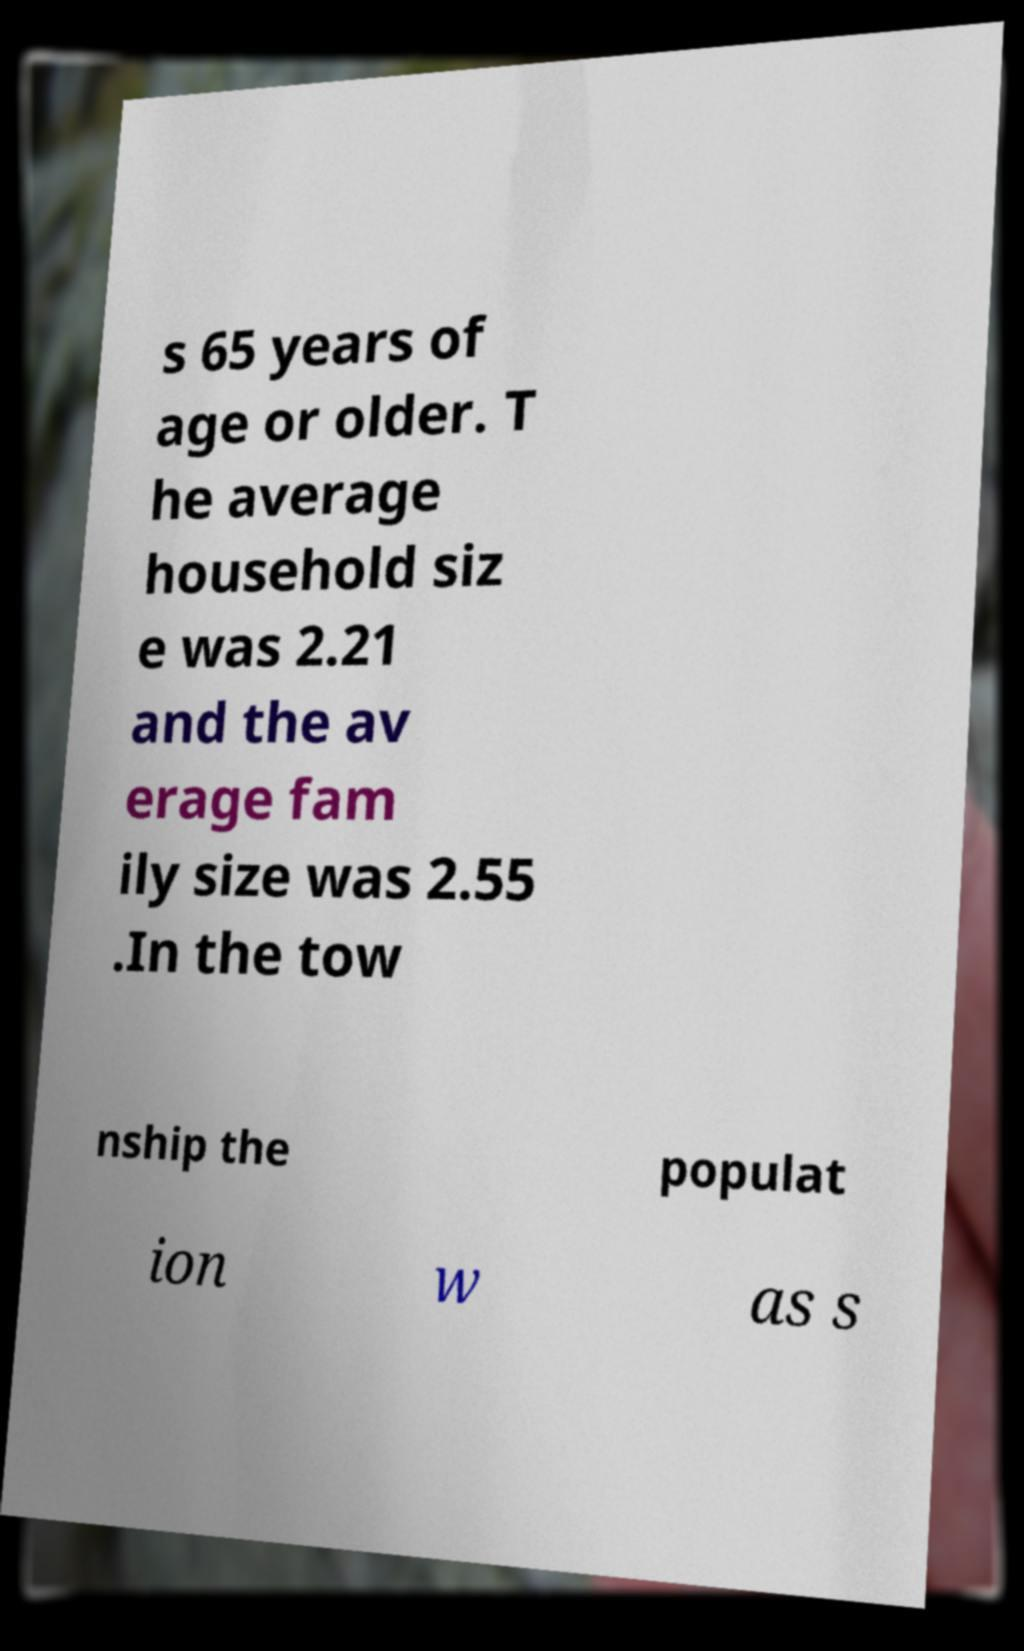There's text embedded in this image that I need extracted. Can you transcribe it verbatim? s 65 years of age or older. T he average household siz e was 2.21 and the av erage fam ily size was 2.55 .In the tow nship the populat ion w as s 